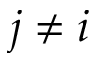<formula> <loc_0><loc_0><loc_500><loc_500>j \neq i</formula> 